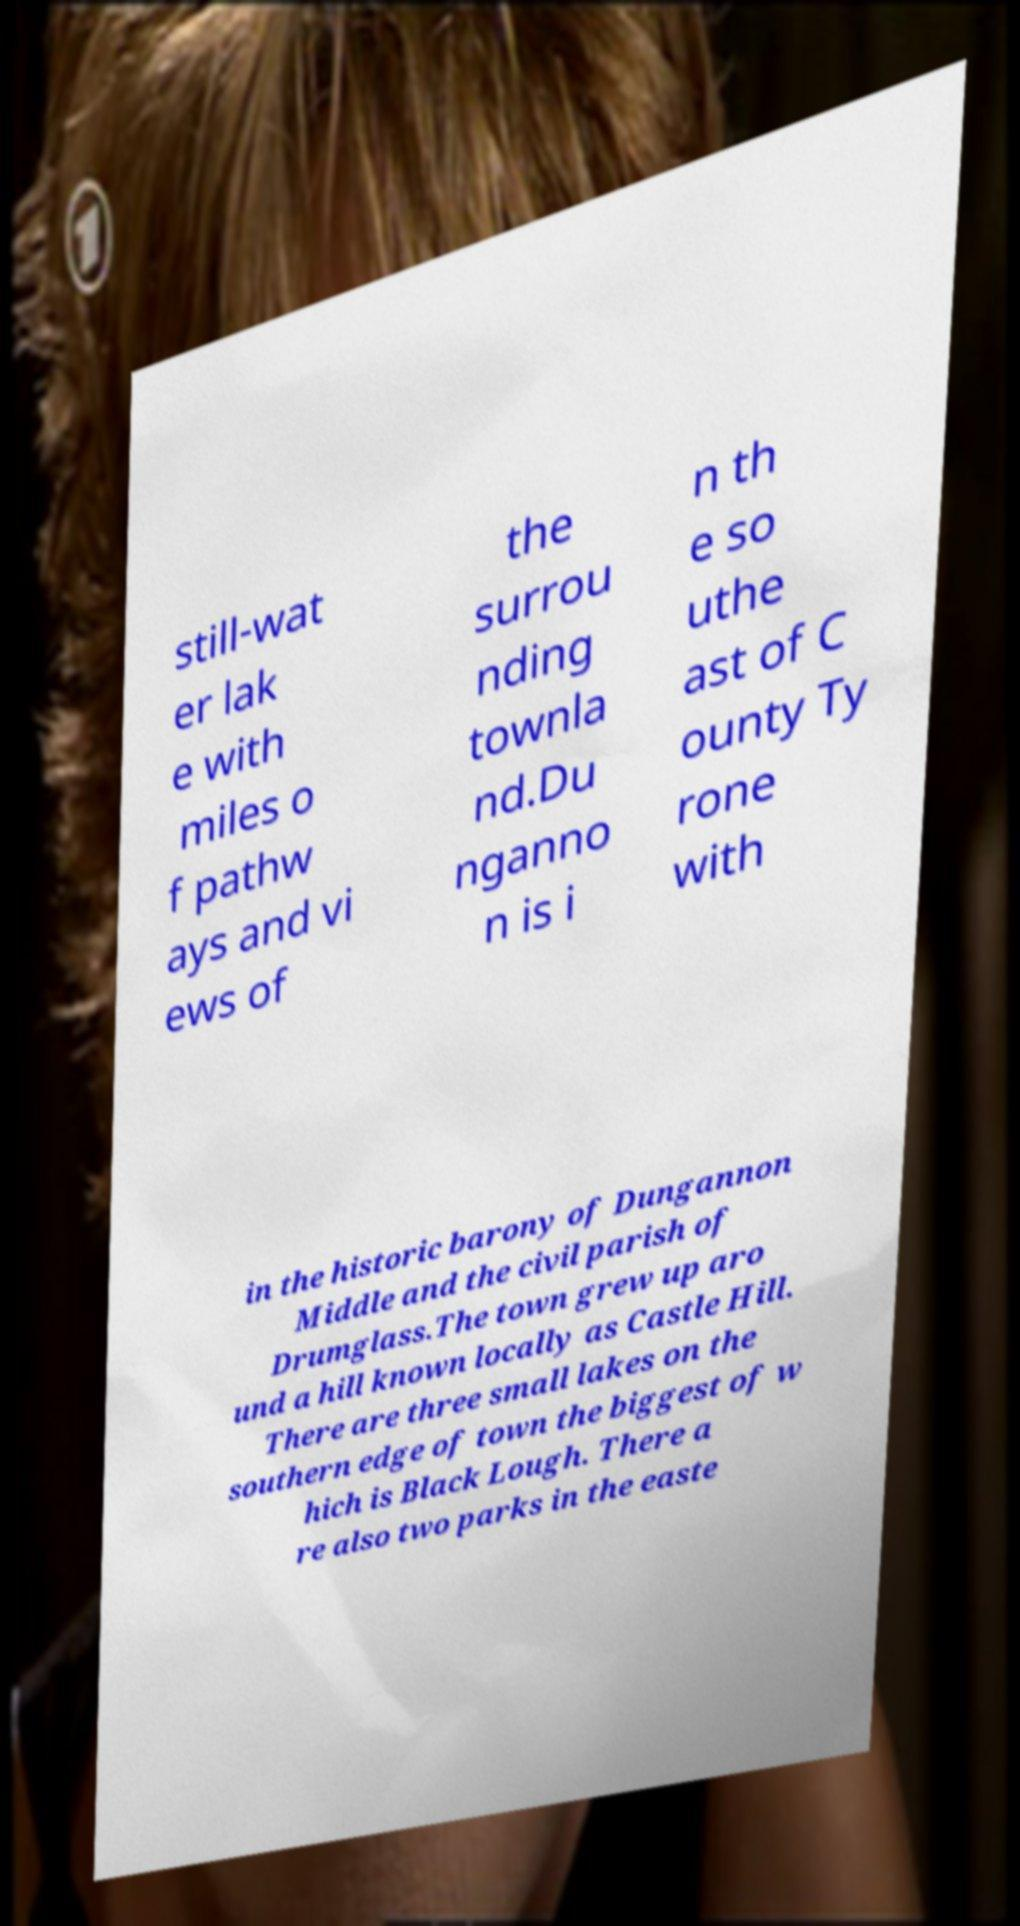Can you read and provide the text displayed in the image?This photo seems to have some interesting text. Can you extract and type it out for me? still-wat er lak e with miles o f pathw ays and vi ews of the surrou nding townla nd.Du nganno n is i n th e so uthe ast of C ounty Ty rone with in the historic barony of Dungannon Middle and the civil parish of Drumglass.The town grew up aro und a hill known locally as Castle Hill. There are three small lakes on the southern edge of town the biggest of w hich is Black Lough. There a re also two parks in the easte 